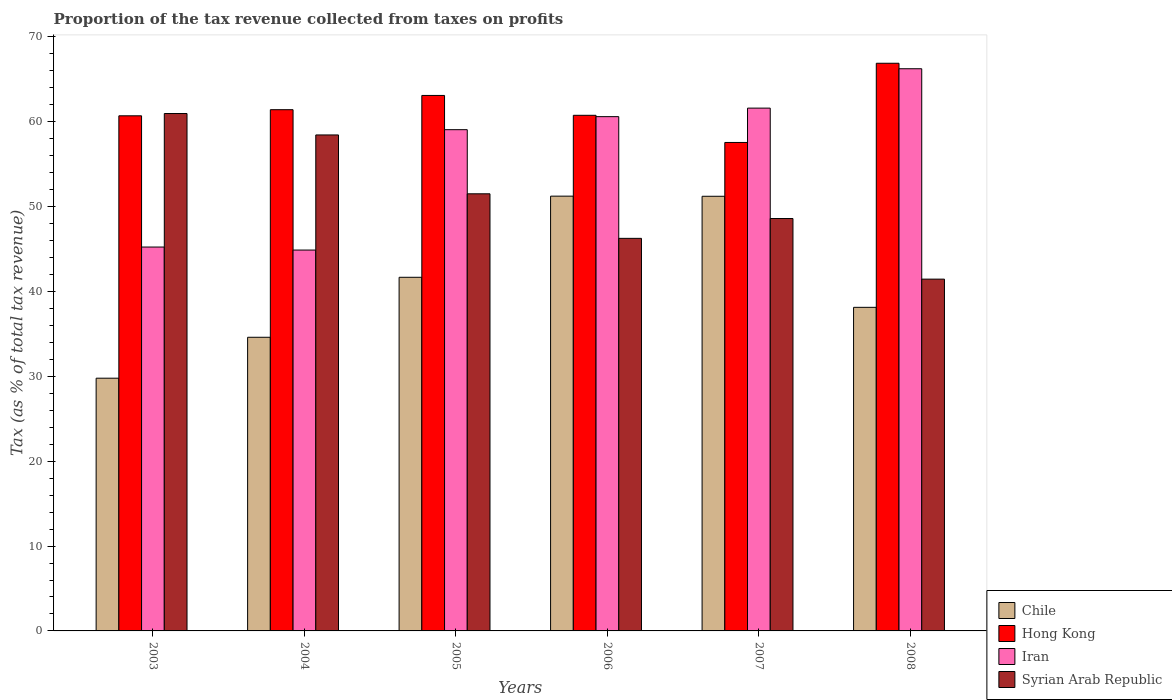How many groups of bars are there?
Give a very brief answer. 6. Are the number of bars on each tick of the X-axis equal?
Your answer should be compact. Yes. How many bars are there on the 1st tick from the right?
Ensure brevity in your answer.  4. What is the label of the 1st group of bars from the left?
Give a very brief answer. 2003. What is the proportion of the tax revenue collected in Hong Kong in 2006?
Keep it short and to the point. 60.77. Across all years, what is the maximum proportion of the tax revenue collected in Chile?
Make the answer very short. 51.24. Across all years, what is the minimum proportion of the tax revenue collected in Chile?
Keep it short and to the point. 29.79. In which year was the proportion of the tax revenue collected in Hong Kong maximum?
Make the answer very short. 2008. In which year was the proportion of the tax revenue collected in Syrian Arab Republic minimum?
Your answer should be very brief. 2008. What is the total proportion of the tax revenue collected in Hong Kong in the graph?
Offer a very short reply. 370.5. What is the difference between the proportion of the tax revenue collected in Iran in 2003 and that in 2007?
Your answer should be compact. -16.37. What is the difference between the proportion of the tax revenue collected in Chile in 2008 and the proportion of the tax revenue collected in Syrian Arab Republic in 2004?
Provide a succinct answer. -20.32. What is the average proportion of the tax revenue collected in Hong Kong per year?
Offer a very short reply. 61.75. In the year 2004, what is the difference between the proportion of the tax revenue collected in Syrian Arab Republic and proportion of the tax revenue collected in Chile?
Your response must be concise. 23.85. What is the ratio of the proportion of the tax revenue collected in Iran in 2004 to that in 2005?
Ensure brevity in your answer.  0.76. Is the proportion of the tax revenue collected in Chile in 2005 less than that in 2007?
Provide a succinct answer. Yes. What is the difference between the highest and the second highest proportion of the tax revenue collected in Chile?
Ensure brevity in your answer.  0.01. What is the difference between the highest and the lowest proportion of the tax revenue collected in Hong Kong?
Your response must be concise. 9.33. In how many years, is the proportion of the tax revenue collected in Syrian Arab Republic greater than the average proportion of the tax revenue collected in Syrian Arab Republic taken over all years?
Offer a terse response. 3. What does the 1st bar from the left in 2003 represents?
Provide a succinct answer. Chile. What does the 1st bar from the right in 2005 represents?
Ensure brevity in your answer.  Syrian Arab Republic. Is it the case that in every year, the sum of the proportion of the tax revenue collected in Syrian Arab Republic and proportion of the tax revenue collected in Chile is greater than the proportion of the tax revenue collected in Hong Kong?
Your response must be concise. Yes. Are all the bars in the graph horizontal?
Your answer should be very brief. No. How many years are there in the graph?
Ensure brevity in your answer.  6. What is the difference between two consecutive major ticks on the Y-axis?
Your answer should be compact. 10. Does the graph contain grids?
Your response must be concise. No. What is the title of the graph?
Your response must be concise. Proportion of the tax revenue collected from taxes on profits. What is the label or title of the X-axis?
Offer a very short reply. Years. What is the label or title of the Y-axis?
Your response must be concise. Tax (as % of total tax revenue). What is the Tax (as % of total tax revenue) of Chile in 2003?
Offer a terse response. 29.79. What is the Tax (as % of total tax revenue) in Hong Kong in 2003?
Offer a terse response. 60.71. What is the Tax (as % of total tax revenue) in Iran in 2003?
Your response must be concise. 45.24. What is the Tax (as % of total tax revenue) in Syrian Arab Republic in 2003?
Ensure brevity in your answer.  60.98. What is the Tax (as % of total tax revenue) of Chile in 2004?
Provide a succinct answer. 34.61. What is the Tax (as % of total tax revenue) of Hong Kong in 2004?
Ensure brevity in your answer.  61.43. What is the Tax (as % of total tax revenue) in Iran in 2004?
Provide a succinct answer. 44.89. What is the Tax (as % of total tax revenue) of Syrian Arab Republic in 2004?
Give a very brief answer. 58.45. What is the Tax (as % of total tax revenue) in Chile in 2005?
Offer a very short reply. 41.68. What is the Tax (as % of total tax revenue) of Hong Kong in 2005?
Provide a short and direct response. 63.11. What is the Tax (as % of total tax revenue) in Iran in 2005?
Your answer should be compact. 59.08. What is the Tax (as % of total tax revenue) of Syrian Arab Republic in 2005?
Give a very brief answer. 51.52. What is the Tax (as % of total tax revenue) in Chile in 2006?
Your answer should be very brief. 51.24. What is the Tax (as % of total tax revenue) of Hong Kong in 2006?
Provide a succinct answer. 60.77. What is the Tax (as % of total tax revenue) in Iran in 2006?
Keep it short and to the point. 60.61. What is the Tax (as % of total tax revenue) of Syrian Arab Republic in 2006?
Give a very brief answer. 46.27. What is the Tax (as % of total tax revenue) in Chile in 2007?
Keep it short and to the point. 51.23. What is the Tax (as % of total tax revenue) of Hong Kong in 2007?
Keep it short and to the point. 57.57. What is the Tax (as % of total tax revenue) in Iran in 2007?
Your response must be concise. 61.62. What is the Tax (as % of total tax revenue) of Syrian Arab Republic in 2007?
Make the answer very short. 48.6. What is the Tax (as % of total tax revenue) in Chile in 2008?
Offer a terse response. 38.14. What is the Tax (as % of total tax revenue) of Hong Kong in 2008?
Give a very brief answer. 66.9. What is the Tax (as % of total tax revenue) in Iran in 2008?
Make the answer very short. 66.26. What is the Tax (as % of total tax revenue) of Syrian Arab Republic in 2008?
Make the answer very short. 41.46. Across all years, what is the maximum Tax (as % of total tax revenue) in Chile?
Ensure brevity in your answer.  51.24. Across all years, what is the maximum Tax (as % of total tax revenue) in Hong Kong?
Your answer should be compact. 66.9. Across all years, what is the maximum Tax (as % of total tax revenue) in Iran?
Provide a succinct answer. 66.26. Across all years, what is the maximum Tax (as % of total tax revenue) of Syrian Arab Republic?
Provide a short and direct response. 60.98. Across all years, what is the minimum Tax (as % of total tax revenue) of Chile?
Your answer should be compact. 29.79. Across all years, what is the minimum Tax (as % of total tax revenue) of Hong Kong?
Keep it short and to the point. 57.57. Across all years, what is the minimum Tax (as % of total tax revenue) of Iran?
Give a very brief answer. 44.89. Across all years, what is the minimum Tax (as % of total tax revenue) in Syrian Arab Republic?
Keep it short and to the point. 41.46. What is the total Tax (as % of total tax revenue) in Chile in the graph?
Your response must be concise. 246.68. What is the total Tax (as % of total tax revenue) in Hong Kong in the graph?
Your answer should be very brief. 370.5. What is the total Tax (as % of total tax revenue) of Iran in the graph?
Provide a short and direct response. 337.69. What is the total Tax (as % of total tax revenue) in Syrian Arab Republic in the graph?
Ensure brevity in your answer.  307.29. What is the difference between the Tax (as % of total tax revenue) of Chile in 2003 and that in 2004?
Provide a succinct answer. -4.82. What is the difference between the Tax (as % of total tax revenue) in Hong Kong in 2003 and that in 2004?
Your answer should be very brief. -0.72. What is the difference between the Tax (as % of total tax revenue) of Iran in 2003 and that in 2004?
Keep it short and to the point. 0.36. What is the difference between the Tax (as % of total tax revenue) in Syrian Arab Republic in 2003 and that in 2004?
Offer a very short reply. 2.53. What is the difference between the Tax (as % of total tax revenue) of Chile in 2003 and that in 2005?
Offer a very short reply. -11.89. What is the difference between the Tax (as % of total tax revenue) in Hong Kong in 2003 and that in 2005?
Your answer should be compact. -2.4. What is the difference between the Tax (as % of total tax revenue) in Iran in 2003 and that in 2005?
Keep it short and to the point. -13.83. What is the difference between the Tax (as % of total tax revenue) in Syrian Arab Republic in 2003 and that in 2005?
Ensure brevity in your answer.  9.46. What is the difference between the Tax (as % of total tax revenue) of Chile in 2003 and that in 2006?
Give a very brief answer. -21.45. What is the difference between the Tax (as % of total tax revenue) in Hong Kong in 2003 and that in 2006?
Offer a terse response. -0.06. What is the difference between the Tax (as % of total tax revenue) in Iran in 2003 and that in 2006?
Ensure brevity in your answer.  -15.37. What is the difference between the Tax (as % of total tax revenue) in Syrian Arab Republic in 2003 and that in 2006?
Provide a short and direct response. 14.71. What is the difference between the Tax (as % of total tax revenue) of Chile in 2003 and that in 2007?
Give a very brief answer. -21.44. What is the difference between the Tax (as % of total tax revenue) of Hong Kong in 2003 and that in 2007?
Provide a short and direct response. 3.14. What is the difference between the Tax (as % of total tax revenue) in Iran in 2003 and that in 2007?
Give a very brief answer. -16.37. What is the difference between the Tax (as % of total tax revenue) in Syrian Arab Republic in 2003 and that in 2007?
Your answer should be very brief. 12.38. What is the difference between the Tax (as % of total tax revenue) in Chile in 2003 and that in 2008?
Give a very brief answer. -8.35. What is the difference between the Tax (as % of total tax revenue) of Hong Kong in 2003 and that in 2008?
Keep it short and to the point. -6.19. What is the difference between the Tax (as % of total tax revenue) of Iran in 2003 and that in 2008?
Your response must be concise. -21.01. What is the difference between the Tax (as % of total tax revenue) in Syrian Arab Republic in 2003 and that in 2008?
Your answer should be compact. 19.52. What is the difference between the Tax (as % of total tax revenue) of Chile in 2004 and that in 2005?
Your response must be concise. -7.07. What is the difference between the Tax (as % of total tax revenue) of Hong Kong in 2004 and that in 2005?
Give a very brief answer. -1.68. What is the difference between the Tax (as % of total tax revenue) in Iran in 2004 and that in 2005?
Offer a very short reply. -14.19. What is the difference between the Tax (as % of total tax revenue) in Syrian Arab Republic in 2004 and that in 2005?
Your answer should be very brief. 6.94. What is the difference between the Tax (as % of total tax revenue) of Chile in 2004 and that in 2006?
Provide a succinct answer. -16.63. What is the difference between the Tax (as % of total tax revenue) of Hong Kong in 2004 and that in 2006?
Give a very brief answer. 0.66. What is the difference between the Tax (as % of total tax revenue) of Iran in 2004 and that in 2006?
Provide a succinct answer. -15.72. What is the difference between the Tax (as % of total tax revenue) in Syrian Arab Republic in 2004 and that in 2006?
Your answer should be very brief. 12.19. What is the difference between the Tax (as % of total tax revenue) of Chile in 2004 and that in 2007?
Offer a terse response. -16.62. What is the difference between the Tax (as % of total tax revenue) of Hong Kong in 2004 and that in 2007?
Provide a succinct answer. 3.86. What is the difference between the Tax (as % of total tax revenue) in Iran in 2004 and that in 2007?
Make the answer very short. -16.73. What is the difference between the Tax (as % of total tax revenue) of Syrian Arab Republic in 2004 and that in 2007?
Ensure brevity in your answer.  9.85. What is the difference between the Tax (as % of total tax revenue) of Chile in 2004 and that in 2008?
Offer a terse response. -3.53. What is the difference between the Tax (as % of total tax revenue) of Hong Kong in 2004 and that in 2008?
Keep it short and to the point. -5.47. What is the difference between the Tax (as % of total tax revenue) in Iran in 2004 and that in 2008?
Offer a terse response. -21.37. What is the difference between the Tax (as % of total tax revenue) in Syrian Arab Republic in 2004 and that in 2008?
Keep it short and to the point. 16.99. What is the difference between the Tax (as % of total tax revenue) of Chile in 2005 and that in 2006?
Give a very brief answer. -9.56. What is the difference between the Tax (as % of total tax revenue) in Hong Kong in 2005 and that in 2006?
Offer a very short reply. 2.34. What is the difference between the Tax (as % of total tax revenue) of Iran in 2005 and that in 2006?
Make the answer very short. -1.54. What is the difference between the Tax (as % of total tax revenue) of Syrian Arab Republic in 2005 and that in 2006?
Give a very brief answer. 5.25. What is the difference between the Tax (as % of total tax revenue) of Chile in 2005 and that in 2007?
Provide a succinct answer. -9.55. What is the difference between the Tax (as % of total tax revenue) in Hong Kong in 2005 and that in 2007?
Ensure brevity in your answer.  5.54. What is the difference between the Tax (as % of total tax revenue) in Iran in 2005 and that in 2007?
Your response must be concise. -2.54. What is the difference between the Tax (as % of total tax revenue) of Syrian Arab Republic in 2005 and that in 2007?
Your response must be concise. 2.91. What is the difference between the Tax (as % of total tax revenue) in Chile in 2005 and that in 2008?
Give a very brief answer. 3.54. What is the difference between the Tax (as % of total tax revenue) in Hong Kong in 2005 and that in 2008?
Your answer should be compact. -3.79. What is the difference between the Tax (as % of total tax revenue) in Iran in 2005 and that in 2008?
Ensure brevity in your answer.  -7.18. What is the difference between the Tax (as % of total tax revenue) in Syrian Arab Republic in 2005 and that in 2008?
Ensure brevity in your answer.  10.06. What is the difference between the Tax (as % of total tax revenue) of Chile in 2006 and that in 2007?
Ensure brevity in your answer.  0.01. What is the difference between the Tax (as % of total tax revenue) in Hong Kong in 2006 and that in 2007?
Your answer should be very brief. 3.2. What is the difference between the Tax (as % of total tax revenue) of Iran in 2006 and that in 2007?
Offer a terse response. -1. What is the difference between the Tax (as % of total tax revenue) of Syrian Arab Republic in 2006 and that in 2007?
Ensure brevity in your answer.  -2.34. What is the difference between the Tax (as % of total tax revenue) of Chile in 2006 and that in 2008?
Offer a very short reply. 13.1. What is the difference between the Tax (as % of total tax revenue) in Hong Kong in 2006 and that in 2008?
Provide a short and direct response. -6.13. What is the difference between the Tax (as % of total tax revenue) in Iran in 2006 and that in 2008?
Keep it short and to the point. -5.64. What is the difference between the Tax (as % of total tax revenue) of Syrian Arab Republic in 2006 and that in 2008?
Keep it short and to the point. 4.81. What is the difference between the Tax (as % of total tax revenue) in Chile in 2007 and that in 2008?
Give a very brief answer. 13.09. What is the difference between the Tax (as % of total tax revenue) in Hong Kong in 2007 and that in 2008?
Provide a short and direct response. -9.33. What is the difference between the Tax (as % of total tax revenue) of Iran in 2007 and that in 2008?
Make the answer very short. -4.64. What is the difference between the Tax (as % of total tax revenue) of Syrian Arab Republic in 2007 and that in 2008?
Keep it short and to the point. 7.14. What is the difference between the Tax (as % of total tax revenue) of Chile in 2003 and the Tax (as % of total tax revenue) of Hong Kong in 2004?
Your response must be concise. -31.65. What is the difference between the Tax (as % of total tax revenue) in Chile in 2003 and the Tax (as % of total tax revenue) in Iran in 2004?
Keep it short and to the point. -15.1. What is the difference between the Tax (as % of total tax revenue) of Chile in 2003 and the Tax (as % of total tax revenue) of Syrian Arab Republic in 2004?
Ensure brevity in your answer.  -28.67. What is the difference between the Tax (as % of total tax revenue) in Hong Kong in 2003 and the Tax (as % of total tax revenue) in Iran in 2004?
Offer a very short reply. 15.82. What is the difference between the Tax (as % of total tax revenue) in Hong Kong in 2003 and the Tax (as % of total tax revenue) in Syrian Arab Republic in 2004?
Ensure brevity in your answer.  2.26. What is the difference between the Tax (as % of total tax revenue) of Iran in 2003 and the Tax (as % of total tax revenue) of Syrian Arab Republic in 2004?
Give a very brief answer. -13.21. What is the difference between the Tax (as % of total tax revenue) in Chile in 2003 and the Tax (as % of total tax revenue) in Hong Kong in 2005?
Your answer should be compact. -33.32. What is the difference between the Tax (as % of total tax revenue) in Chile in 2003 and the Tax (as % of total tax revenue) in Iran in 2005?
Your answer should be compact. -29.29. What is the difference between the Tax (as % of total tax revenue) in Chile in 2003 and the Tax (as % of total tax revenue) in Syrian Arab Republic in 2005?
Give a very brief answer. -21.73. What is the difference between the Tax (as % of total tax revenue) in Hong Kong in 2003 and the Tax (as % of total tax revenue) in Iran in 2005?
Ensure brevity in your answer.  1.64. What is the difference between the Tax (as % of total tax revenue) of Hong Kong in 2003 and the Tax (as % of total tax revenue) of Syrian Arab Republic in 2005?
Give a very brief answer. 9.19. What is the difference between the Tax (as % of total tax revenue) of Iran in 2003 and the Tax (as % of total tax revenue) of Syrian Arab Republic in 2005?
Your response must be concise. -6.27. What is the difference between the Tax (as % of total tax revenue) of Chile in 2003 and the Tax (as % of total tax revenue) of Hong Kong in 2006?
Give a very brief answer. -30.98. What is the difference between the Tax (as % of total tax revenue) in Chile in 2003 and the Tax (as % of total tax revenue) in Iran in 2006?
Give a very brief answer. -30.83. What is the difference between the Tax (as % of total tax revenue) in Chile in 2003 and the Tax (as % of total tax revenue) in Syrian Arab Republic in 2006?
Provide a succinct answer. -16.48. What is the difference between the Tax (as % of total tax revenue) in Hong Kong in 2003 and the Tax (as % of total tax revenue) in Iran in 2006?
Ensure brevity in your answer.  0.1. What is the difference between the Tax (as % of total tax revenue) in Hong Kong in 2003 and the Tax (as % of total tax revenue) in Syrian Arab Republic in 2006?
Provide a short and direct response. 14.44. What is the difference between the Tax (as % of total tax revenue) of Iran in 2003 and the Tax (as % of total tax revenue) of Syrian Arab Republic in 2006?
Your response must be concise. -1.02. What is the difference between the Tax (as % of total tax revenue) of Chile in 2003 and the Tax (as % of total tax revenue) of Hong Kong in 2007?
Your answer should be compact. -27.78. What is the difference between the Tax (as % of total tax revenue) in Chile in 2003 and the Tax (as % of total tax revenue) in Iran in 2007?
Your response must be concise. -31.83. What is the difference between the Tax (as % of total tax revenue) in Chile in 2003 and the Tax (as % of total tax revenue) in Syrian Arab Republic in 2007?
Your answer should be very brief. -18.82. What is the difference between the Tax (as % of total tax revenue) of Hong Kong in 2003 and the Tax (as % of total tax revenue) of Iran in 2007?
Provide a succinct answer. -0.91. What is the difference between the Tax (as % of total tax revenue) of Hong Kong in 2003 and the Tax (as % of total tax revenue) of Syrian Arab Republic in 2007?
Your answer should be compact. 12.11. What is the difference between the Tax (as % of total tax revenue) in Iran in 2003 and the Tax (as % of total tax revenue) in Syrian Arab Republic in 2007?
Offer a very short reply. -3.36. What is the difference between the Tax (as % of total tax revenue) in Chile in 2003 and the Tax (as % of total tax revenue) in Hong Kong in 2008?
Your answer should be very brief. -37.12. What is the difference between the Tax (as % of total tax revenue) of Chile in 2003 and the Tax (as % of total tax revenue) of Iran in 2008?
Your response must be concise. -36.47. What is the difference between the Tax (as % of total tax revenue) in Chile in 2003 and the Tax (as % of total tax revenue) in Syrian Arab Republic in 2008?
Offer a very short reply. -11.68. What is the difference between the Tax (as % of total tax revenue) of Hong Kong in 2003 and the Tax (as % of total tax revenue) of Iran in 2008?
Offer a very short reply. -5.55. What is the difference between the Tax (as % of total tax revenue) of Hong Kong in 2003 and the Tax (as % of total tax revenue) of Syrian Arab Republic in 2008?
Ensure brevity in your answer.  19.25. What is the difference between the Tax (as % of total tax revenue) of Iran in 2003 and the Tax (as % of total tax revenue) of Syrian Arab Republic in 2008?
Provide a succinct answer. 3.78. What is the difference between the Tax (as % of total tax revenue) of Chile in 2004 and the Tax (as % of total tax revenue) of Hong Kong in 2005?
Your answer should be compact. -28.5. What is the difference between the Tax (as % of total tax revenue) in Chile in 2004 and the Tax (as % of total tax revenue) in Iran in 2005?
Your response must be concise. -24.47. What is the difference between the Tax (as % of total tax revenue) in Chile in 2004 and the Tax (as % of total tax revenue) in Syrian Arab Republic in 2005?
Offer a terse response. -16.91. What is the difference between the Tax (as % of total tax revenue) of Hong Kong in 2004 and the Tax (as % of total tax revenue) of Iran in 2005?
Offer a terse response. 2.36. What is the difference between the Tax (as % of total tax revenue) in Hong Kong in 2004 and the Tax (as % of total tax revenue) in Syrian Arab Republic in 2005?
Give a very brief answer. 9.91. What is the difference between the Tax (as % of total tax revenue) of Iran in 2004 and the Tax (as % of total tax revenue) of Syrian Arab Republic in 2005?
Ensure brevity in your answer.  -6.63. What is the difference between the Tax (as % of total tax revenue) of Chile in 2004 and the Tax (as % of total tax revenue) of Hong Kong in 2006?
Provide a short and direct response. -26.16. What is the difference between the Tax (as % of total tax revenue) of Chile in 2004 and the Tax (as % of total tax revenue) of Iran in 2006?
Provide a short and direct response. -26. What is the difference between the Tax (as % of total tax revenue) of Chile in 2004 and the Tax (as % of total tax revenue) of Syrian Arab Republic in 2006?
Your response must be concise. -11.66. What is the difference between the Tax (as % of total tax revenue) in Hong Kong in 2004 and the Tax (as % of total tax revenue) in Iran in 2006?
Provide a short and direct response. 0.82. What is the difference between the Tax (as % of total tax revenue) of Hong Kong in 2004 and the Tax (as % of total tax revenue) of Syrian Arab Republic in 2006?
Ensure brevity in your answer.  15.16. What is the difference between the Tax (as % of total tax revenue) in Iran in 2004 and the Tax (as % of total tax revenue) in Syrian Arab Republic in 2006?
Offer a terse response. -1.38. What is the difference between the Tax (as % of total tax revenue) in Chile in 2004 and the Tax (as % of total tax revenue) in Hong Kong in 2007?
Your answer should be compact. -22.96. What is the difference between the Tax (as % of total tax revenue) in Chile in 2004 and the Tax (as % of total tax revenue) in Iran in 2007?
Make the answer very short. -27.01. What is the difference between the Tax (as % of total tax revenue) of Chile in 2004 and the Tax (as % of total tax revenue) of Syrian Arab Republic in 2007?
Provide a succinct answer. -14. What is the difference between the Tax (as % of total tax revenue) of Hong Kong in 2004 and the Tax (as % of total tax revenue) of Iran in 2007?
Your answer should be compact. -0.18. What is the difference between the Tax (as % of total tax revenue) in Hong Kong in 2004 and the Tax (as % of total tax revenue) in Syrian Arab Republic in 2007?
Give a very brief answer. 12.83. What is the difference between the Tax (as % of total tax revenue) in Iran in 2004 and the Tax (as % of total tax revenue) in Syrian Arab Republic in 2007?
Your answer should be very brief. -3.72. What is the difference between the Tax (as % of total tax revenue) of Chile in 2004 and the Tax (as % of total tax revenue) of Hong Kong in 2008?
Your response must be concise. -32.3. What is the difference between the Tax (as % of total tax revenue) of Chile in 2004 and the Tax (as % of total tax revenue) of Iran in 2008?
Your answer should be very brief. -31.65. What is the difference between the Tax (as % of total tax revenue) in Chile in 2004 and the Tax (as % of total tax revenue) in Syrian Arab Republic in 2008?
Your answer should be very brief. -6.85. What is the difference between the Tax (as % of total tax revenue) of Hong Kong in 2004 and the Tax (as % of total tax revenue) of Iran in 2008?
Offer a very short reply. -4.83. What is the difference between the Tax (as % of total tax revenue) in Hong Kong in 2004 and the Tax (as % of total tax revenue) in Syrian Arab Republic in 2008?
Offer a very short reply. 19.97. What is the difference between the Tax (as % of total tax revenue) of Iran in 2004 and the Tax (as % of total tax revenue) of Syrian Arab Republic in 2008?
Offer a terse response. 3.43. What is the difference between the Tax (as % of total tax revenue) of Chile in 2005 and the Tax (as % of total tax revenue) of Hong Kong in 2006?
Offer a terse response. -19.09. What is the difference between the Tax (as % of total tax revenue) in Chile in 2005 and the Tax (as % of total tax revenue) in Iran in 2006?
Ensure brevity in your answer.  -18.93. What is the difference between the Tax (as % of total tax revenue) in Chile in 2005 and the Tax (as % of total tax revenue) in Syrian Arab Republic in 2006?
Provide a succinct answer. -4.59. What is the difference between the Tax (as % of total tax revenue) of Hong Kong in 2005 and the Tax (as % of total tax revenue) of Iran in 2006?
Keep it short and to the point. 2.5. What is the difference between the Tax (as % of total tax revenue) of Hong Kong in 2005 and the Tax (as % of total tax revenue) of Syrian Arab Republic in 2006?
Your answer should be very brief. 16.84. What is the difference between the Tax (as % of total tax revenue) in Iran in 2005 and the Tax (as % of total tax revenue) in Syrian Arab Republic in 2006?
Offer a terse response. 12.81. What is the difference between the Tax (as % of total tax revenue) in Chile in 2005 and the Tax (as % of total tax revenue) in Hong Kong in 2007?
Your response must be concise. -15.89. What is the difference between the Tax (as % of total tax revenue) of Chile in 2005 and the Tax (as % of total tax revenue) of Iran in 2007?
Offer a very short reply. -19.94. What is the difference between the Tax (as % of total tax revenue) of Chile in 2005 and the Tax (as % of total tax revenue) of Syrian Arab Republic in 2007?
Offer a terse response. -6.93. What is the difference between the Tax (as % of total tax revenue) in Hong Kong in 2005 and the Tax (as % of total tax revenue) in Iran in 2007?
Give a very brief answer. 1.49. What is the difference between the Tax (as % of total tax revenue) of Hong Kong in 2005 and the Tax (as % of total tax revenue) of Syrian Arab Republic in 2007?
Provide a succinct answer. 14.51. What is the difference between the Tax (as % of total tax revenue) in Iran in 2005 and the Tax (as % of total tax revenue) in Syrian Arab Republic in 2007?
Keep it short and to the point. 10.47. What is the difference between the Tax (as % of total tax revenue) in Chile in 2005 and the Tax (as % of total tax revenue) in Hong Kong in 2008?
Ensure brevity in your answer.  -25.23. What is the difference between the Tax (as % of total tax revenue) in Chile in 2005 and the Tax (as % of total tax revenue) in Iran in 2008?
Give a very brief answer. -24.58. What is the difference between the Tax (as % of total tax revenue) of Chile in 2005 and the Tax (as % of total tax revenue) of Syrian Arab Republic in 2008?
Give a very brief answer. 0.22. What is the difference between the Tax (as % of total tax revenue) in Hong Kong in 2005 and the Tax (as % of total tax revenue) in Iran in 2008?
Give a very brief answer. -3.15. What is the difference between the Tax (as % of total tax revenue) in Hong Kong in 2005 and the Tax (as % of total tax revenue) in Syrian Arab Republic in 2008?
Your response must be concise. 21.65. What is the difference between the Tax (as % of total tax revenue) of Iran in 2005 and the Tax (as % of total tax revenue) of Syrian Arab Republic in 2008?
Your answer should be compact. 17.61. What is the difference between the Tax (as % of total tax revenue) in Chile in 2006 and the Tax (as % of total tax revenue) in Hong Kong in 2007?
Ensure brevity in your answer.  -6.33. What is the difference between the Tax (as % of total tax revenue) in Chile in 2006 and the Tax (as % of total tax revenue) in Iran in 2007?
Provide a short and direct response. -10.38. What is the difference between the Tax (as % of total tax revenue) of Chile in 2006 and the Tax (as % of total tax revenue) of Syrian Arab Republic in 2007?
Your answer should be very brief. 2.64. What is the difference between the Tax (as % of total tax revenue) in Hong Kong in 2006 and the Tax (as % of total tax revenue) in Iran in 2007?
Provide a short and direct response. -0.85. What is the difference between the Tax (as % of total tax revenue) in Hong Kong in 2006 and the Tax (as % of total tax revenue) in Syrian Arab Republic in 2007?
Offer a very short reply. 12.17. What is the difference between the Tax (as % of total tax revenue) in Iran in 2006 and the Tax (as % of total tax revenue) in Syrian Arab Republic in 2007?
Give a very brief answer. 12.01. What is the difference between the Tax (as % of total tax revenue) in Chile in 2006 and the Tax (as % of total tax revenue) in Hong Kong in 2008?
Give a very brief answer. -15.66. What is the difference between the Tax (as % of total tax revenue) of Chile in 2006 and the Tax (as % of total tax revenue) of Iran in 2008?
Make the answer very short. -15.02. What is the difference between the Tax (as % of total tax revenue) of Chile in 2006 and the Tax (as % of total tax revenue) of Syrian Arab Republic in 2008?
Make the answer very short. 9.78. What is the difference between the Tax (as % of total tax revenue) of Hong Kong in 2006 and the Tax (as % of total tax revenue) of Iran in 2008?
Your response must be concise. -5.49. What is the difference between the Tax (as % of total tax revenue) of Hong Kong in 2006 and the Tax (as % of total tax revenue) of Syrian Arab Republic in 2008?
Offer a terse response. 19.31. What is the difference between the Tax (as % of total tax revenue) in Iran in 2006 and the Tax (as % of total tax revenue) in Syrian Arab Republic in 2008?
Offer a very short reply. 19.15. What is the difference between the Tax (as % of total tax revenue) of Chile in 2007 and the Tax (as % of total tax revenue) of Hong Kong in 2008?
Ensure brevity in your answer.  -15.68. What is the difference between the Tax (as % of total tax revenue) of Chile in 2007 and the Tax (as % of total tax revenue) of Iran in 2008?
Give a very brief answer. -15.03. What is the difference between the Tax (as % of total tax revenue) in Chile in 2007 and the Tax (as % of total tax revenue) in Syrian Arab Republic in 2008?
Your response must be concise. 9.76. What is the difference between the Tax (as % of total tax revenue) of Hong Kong in 2007 and the Tax (as % of total tax revenue) of Iran in 2008?
Give a very brief answer. -8.69. What is the difference between the Tax (as % of total tax revenue) in Hong Kong in 2007 and the Tax (as % of total tax revenue) in Syrian Arab Republic in 2008?
Your answer should be very brief. 16.11. What is the difference between the Tax (as % of total tax revenue) in Iran in 2007 and the Tax (as % of total tax revenue) in Syrian Arab Republic in 2008?
Give a very brief answer. 20.15. What is the average Tax (as % of total tax revenue) of Chile per year?
Offer a terse response. 41.11. What is the average Tax (as % of total tax revenue) in Hong Kong per year?
Your answer should be very brief. 61.75. What is the average Tax (as % of total tax revenue) in Iran per year?
Keep it short and to the point. 56.28. What is the average Tax (as % of total tax revenue) in Syrian Arab Republic per year?
Your answer should be compact. 51.21. In the year 2003, what is the difference between the Tax (as % of total tax revenue) of Chile and Tax (as % of total tax revenue) of Hong Kong?
Give a very brief answer. -30.93. In the year 2003, what is the difference between the Tax (as % of total tax revenue) in Chile and Tax (as % of total tax revenue) in Iran?
Your answer should be very brief. -15.46. In the year 2003, what is the difference between the Tax (as % of total tax revenue) in Chile and Tax (as % of total tax revenue) in Syrian Arab Republic?
Ensure brevity in your answer.  -31.19. In the year 2003, what is the difference between the Tax (as % of total tax revenue) in Hong Kong and Tax (as % of total tax revenue) in Iran?
Your response must be concise. 15.47. In the year 2003, what is the difference between the Tax (as % of total tax revenue) in Hong Kong and Tax (as % of total tax revenue) in Syrian Arab Republic?
Provide a short and direct response. -0.27. In the year 2003, what is the difference between the Tax (as % of total tax revenue) of Iran and Tax (as % of total tax revenue) of Syrian Arab Republic?
Ensure brevity in your answer.  -15.74. In the year 2004, what is the difference between the Tax (as % of total tax revenue) in Chile and Tax (as % of total tax revenue) in Hong Kong?
Provide a succinct answer. -26.82. In the year 2004, what is the difference between the Tax (as % of total tax revenue) of Chile and Tax (as % of total tax revenue) of Iran?
Your answer should be compact. -10.28. In the year 2004, what is the difference between the Tax (as % of total tax revenue) of Chile and Tax (as % of total tax revenue) of Syrian Arab Republic?
Provide a succinct answer. -23.85. In the year 2004, what is the difference between the Tax (as % of total tax revenue) of Hong Kong and Tax (as % of total tax revenue) of Iran?
Provide a short and direct response. 16.54. In the year 2004, what is the difference between the Tax (as % of total tax revenue) of Hong Kong and Tax (as % of total tax revenue) of Syrian Arab Republic?
Offer a terse response. 2.98. In the year 2004, what is the difference between the Tax (as % of total tax revenue) in Iran and Tax (as % of total tax revenue) in Syrian Arab Republic?
Ensure brevity in your answer.  -13.57. In the year 2005, what is the difference between the Tax (as % of total tax revenue) in Chile and Tax (as % of total tax revenue) in Hong Kong?
Your answer should be compact. -21.43. In the year 2005, what is the difference between the Tax (as % of total tax revenue) of Chile and Tax (as % of total tax revenue) of Iran?
Keep it short and to the point. -17.4. In the year 2005, what is the difference between the Tax (as % of total tax revenue) of Chile and Tax (as % of total tax revenue) of Syrian Arab Republic?
Your answer should be very brief. -9.84. In the year 2005, what is the difference between the Tax (as % of total tax revenue) of Hong Kong and Tax (as % of total tax revenue) of Iran?
Make the answer very short. 4.03. In the year 2005, what is the difference between the Tax (as % of total tax revenue) in Hong Kong and Tax (as % of total tax revenue) in Syrian Arab Republic?
Your answer should be compact. 11.59. In the year 2005, what is the difference between the Tax (as % of total tax revenue) of Iran and Tax (as % of total tax revenue) of Syrian Arab Republic?
Offer a terse response. 7.56. In the year 2006, what is the difference between the Tax (as % of total tax revenue) in Chile and Tax (as % of total tax revenue) in Hong Kong?
Your answer should be compact. -9.53. In the year 2006, what is the difference between the Tax (as % of total tax revenue) in Chile and Tax (as % of total tax revenue) in Iran?
Your response must be concise. -9.37. In the year 2006, what is the difference between the Tax (as % of total tax revenue) of Chile and Tax (as % of total tax revenue) of Syrian Arab Republic?
Give a very brief answer. 4.97. In the year 2006, what is the difference between the Tax (as % of total tax revenue) in Hong Kong and Tax (as % of total tax revenue) in Iran?
Your answer should be very brief. 0.16. In the year 2006, what is the difference between the Tax (as % of total tax revenue) of Hong Kong and Tax (as % of total tax revenue) of Syrian Arab Republic?
Provide a succinct answer. 14.5. In the year 2006, what is the difference between the Tax (as % of total tax revenue) of Iran and Tax (as % of total tax revenue) of Syrian Arab Republic?
Your answer should be very brief. 14.34. In the year 2007, what is the difference between the Tax (as % of total tax revenue) in Chile and Tax (as % of total tax revenue) in Hong Kong?
Your answer should be very brief. -6.34. In the year 2007, what is the difference between the Tax (as % of total tax revenue) of Chile and Tax (as % of total tax revenue) of Iran?
Give a very brief answer. -10.39. In the year 2007, what is the difference between the Tax (as % of total tax revenue) of Chile and Tax (as % of total tax revenue) of Syrian Arab Republic?
Ensure brevity in your answer.  2.62. In the year 2007, what is the difference between the Tax (as % of total tax revenue) of Hong Kong and Tax (as % of total tax revenue) of Iran?
Give a very brief answer. -4.05. In the year 2007, what is the difference between the Tax (as % of total tax revenue) in Hong Kong and Tax (as % of total tax revenue) in Syrian Arab Republic?
Give a very brief answer. 8.97. In the year 2007, what is the difference between the Tax (as % of total tax revenue) of Iran and Tax (as % of total tax revenue) of Syrian Arab Republic?
Offer a terse response. 13.01. In the year 2008, what is the difference between the Tax (as % of total tax revenue) in Chile and Tax (as % of total tax revenue) in Hong Kong?
Your answer should be compact. -28.77. In the year 2008, what is the difference between the Tax (as % of total tax revenue) of Chile and Tax (as % of total tax revenue) of Iran?
Offer a terse response. -28.12. In the year 2008, what is the difference between the Tax (as % of total tax revenue) in Chile and Tax (as % of total tax revenue) in Syrian Arab Republic?
Offer a very short reply. -3.32. In the year 2008, what is the difference between the Tax (as % of total tax revenue) in Hong Kong and Tax (as % of total tax revenue) in Iran?
Your answer should be very brief. 0.65. In the year 2008, what is the difference between the Tax (as % of total tax revenue) of Hong Kong and Tax (as % of total tax revenue) of Syrian Arab Republic?
Your answer should be very brief. 25.44. In the year 2008, what is the difference between the Tax (as % of total tax revenue) of Iran and Tax (as % of total tax revenue) of Syrian Arab Republic?
Ensure brevity in your answer.  24.79. What is the ratio of the Tax (as % of total tax revenue) of Chile in 2003 to that in 2004?
Make the answer very short. 0.86. What is the ratio of the Tax (as % of total tax revenue) of Hong Kong in 2003 to that in 2004?
Your answer should be compact. 0.99. What is the ratio of the Tax (as % of total tax revenue) of Iran in 2003 to that in 2004?
Give a very brief answer. 1.01. What is the ratio of the Tax (as % of total tax revenue) in Syrian Arab Republic in 2003 to that in 2004?
Your response must be concise. 1.04. What is the ratio of the Tax (as % of total tax revenue) of Chile in 2003 to that in 2005?
Offer a very short reply. 0.71. What is the ratio of the Tax (as % of total tax revenue) in Hong Kong in 2003 to that in 2005?
Ensure brevity in your answer.  0.96. What is the ratio of the Tax (as % of total tax revenue) in Iran in 2003 to that in 2005?
Make the answer very short. 0.77. What is the ratio of the Tax (as % of total tax revenue) in Syrian Arab Republic in 2003 to that in 2005?
Give a very brief answer. 1.18. What is the ratio of the Tax (as % of total tax revenue) of Chile in 2003 to that in 2006?
Your response must be concise. 0.58. What is the ratio of the Tax (as % of total tax revenue) in Hong Kong in 2003 to that in 2006?
Your answer should be very brief. 1. What is the ratio of the Tax (as % of total tax revenue) of Iran in 2003 to that in 2006?
Ensure brevity in your answer.  0.75. What is the ratio of the Tax (as % of total tax revenue) in Syrian Arab Republic in 2003 to that in 2006?
Provide a short and direct response. 1.32. What is the ratio of the Tax (as % of total tax revenue) of Chile in 2003 to that in 2007?
Keep it short and to the point. 0.58. What is the ratio of the Tax (as % of total tax revenue) in Hong Kong in 2003 to that in 2007?
Your response must be concise. 1.05. What is the ratio of the Tax (as % of total tax revenue) in Iran in 2003 to that in 2007?
Your response must be concise. 0.73. What is the ratio of the Tax (as % of total tax revenue) in Syrian Arab Republic in 2003 to that in 2007?
Keep it short and to the point. 1.25. What is the ratio of the Tax (as % of total tax revenue) in Chile in 2003 to that in 2008?
Give a very brief answer. 0.78. What is the ratio of the Tax (as % of total tax revenue) in Hong Kong in 2003 to that in 2008?
Offer a very short reply. 0.91. What is the ratio of the Tax (as % of total tax revenue) in Iran in 2003 to that in 2008?
Your answer should be very brief. 0.68. What is the ratio of the Tax (as % of total tax revenue) in Syrian Arab Republic in 2003 to that in 2008?
Make the answer very short. 1.47. What is the ratio of the Tax (as % of total tax revenue) of Chile in 2004 to that in 2005?
Provide a short and direct response. 0.83. What is the ratio of the Tax (as % of total tax revenue) in Hong Kong in 2004 to that in 2005?
Give a very brief answer. 0.97. What is the ratio of the Tax (as % of total tax revenue) in Iran in 2004 to that in 2005?
Your answer should be compact. 0.76. What is the ratio of the Tax (as % of total tax revenue) in Syrian Arab Republic in 2004 to that in 2005?
Offer a very short reply. 1.13. What is the ratio of the Tax (as % of total tax revenue) in Chile in 2004 to that in 2006?
Offer a very short reply. 0.68. What is the ratio of the Tax (as % of total tax revenue) in Hong Kong in 2004 to that in 2006?
Keep it short and to the point. 1.01. What is the ratio of the Tax (as % of total tax revenue) of Iran in 2004 to that in 2006?
Keep it short and to the point. 0.74. What is the ratio of the Tax (as % of total tax revenue) in Syrian Arab Republic in 2004 to that in 2006?
Offer a terse response. 1.26. What is the ratio of the Tax (as % of total tax revenue) in Chile in 2004 to that in 2007?
Provide a succinct answer. 0.68. What is the ratio of the Tax (as % of total tax revenue) in Hong Kong in 2004 to that in 2007?
Offer a very short reply. 1.07. What is the ratio of the Tax (as % of total tax revenue) in Iran in 2004 to that in 2007?
Make the answer very short. 0.73. What is the ratio of the Tax (as % of total tax revenue) of Syrian Arab Republic in 2004 to that in 2007?
Ensure brevity in your answer.  1.2. What is the ratio of the Tax (as % of total tax revenue) of Chile in 2004 to that in 2008?
Provide a short and direct response. 0.91. What is the ratio of the Tax (as % of total tax revenue) of Hong Kong in 2004 to that in 2008?
Provide a succinct answer. 0.92. What is the ratio of the Tax (as % of total tax revenue) in Iran in 2004 to that in 2008?
Give a very brief answer. 0.68. What is the ratio of the Tax (as % of total tax revenue) of Syrian Arab Republic in 2004 to that in 2008?
Your answer should be very brief. 1.41. What is the ratio of the Tax (as % of total tax revenue) in Chile in 2005 to that in 2006?
Offer a very short reply. 0.81. What is the ratio of the Tax (as % of total tax revenue) of Hong Kong in 2005 to that in 2006?
Your answer should be very brief. 1.04. What is the ratio of the Tax (as % of total tax revenue) of Iran in 2005 to that in 2006?
Give a very brief answer. 0.97. What is the ratio of the Tax (as % of total tax revenue) in Syrian Arab Republic in 2005 to that in 2006?
Provide a succinct answer. 1.11. What is the ratio of the Tax (as % of total tax revenue) in Chile in 2005 to that in 2007?
Provide a succinct answer. 0.81. What is the ratio of the Tax (as % of total tax revenue) in Hong Kong in 2005 to that in 2007?
Your answer should be compact. 1.1. What is the ratio of the Tax (as % of total tax revenue) of Iran in 2005 to that in 2007?
Provide a short and direct response. 0.96. What is the ratio of the Tax (as % of total tax revenue) of Syrian Arab Republic in 2005 to that in 2007?
Keep it short and to the point. 1.06. What is the ratio of the Tax (as % of total tax revenue) of Chile in 2005 to that in 2008?
Provide a short and direct response. 1.09. What is the ratio of the Tax (as % of total tax revenue) in Hong Kong in 2005 to that in 2008?
Provide a short and direct response. 0.94. What is the ratio of the Tax (as % of total tax revenue) of Iran in 2005 to that in 2008?
Make the answer very short. 0.89. What is the ratio of the Tax (as % of total tax revenue) in Syrian Arab Republic in 2005 to that in 2008?
Keep it short and to the point. 1.24. What is the ratio of the Tax (as % of total tax revenue) in Chile in 2006 to that in 2007?
Your answer should be compact. 1. What is the ratio of the Tax (as % of total tax revenue) of Hong Kong in 2006 to that in 2007?
Your answer should be compact. 1.06. What is the ratio of the Tax (as % of total tax revenue) in Iran in 2006 to that in 2007?
Offer a terse response. 0.98. What is the ratio of the Tax (as % of total tax revenue) of Syrian Arab Republic in 2006 to that in 2007?
Provide a succinct answer. 0.95. What is the ratio of the Tax (as % of total tax revenue) in Chile in 2006 to that in 2008?
Your answer should be very brief. 1.34. What is the ratio of the Tax (as % of total tax revenue) in Hong Kong in 2006 to that in 2008?
Offer a terse response. 0.91. What is the ratio of the Tax (as % of total tax revenue) of Iran in 2006 to that in 2008?
Your response must be concise. 0.91. What is the ratio of the Tax (as % of total tax revenue) in Syrian Arab Republic in 2006 to that in 2008?
Your response must be concise. 1.12. What is the ratio of the Tax (as % of total tax revenue) of Chile in 2007 to that in 2008?
Your answer should be compact. 1.34. What is the ratio of the Tax (as % of total tax revenue) of Hong Kong in 2007 to that in 2008?
Keep it short and to the point. 0.86. What is the ratio of the Tax (as % of total tax revenue) in Syrian Arab Republic in 2007 to that in 2008?
Keep it short and to the point. 1.17. What is the difference between the highest and the second highest Tax (as % of total tax revenue) of Chile?
Provide a short and direct response. 0.01. What is the difference between the highest and the second highest Tax (as % of total tax revenue) of Hong Kong?
Your response must be concise. 3.79. What is the difference between the highest and the second highest Tax (as % of total tax revenue) of Iran?
Make the answer very short. 4.64. What is the difference between the highest and the second highest Tax (as % of total tax revenue) in Syrian Arab Republic?
Offer a terse response. 2.53. What is the difference between the highest and the lowest Tax (as % of total tax revenue) of Chile?
Your answer should be compact. 21.45. What is the difference between the highest and the lowest Tax (as % of total tax revenue) of Hong Kong?
Offer a very short reply. 9.33. What is the difference between the highest and the lowest Tax (as % of total tax revenue) in Iran?
Your answer should be very brief. 21.37. What is the difference between the highest and the lowest Tax (as % of total tax revenue) in Syrian Arab Republic?
Provide a short and direct response. 19.52. 